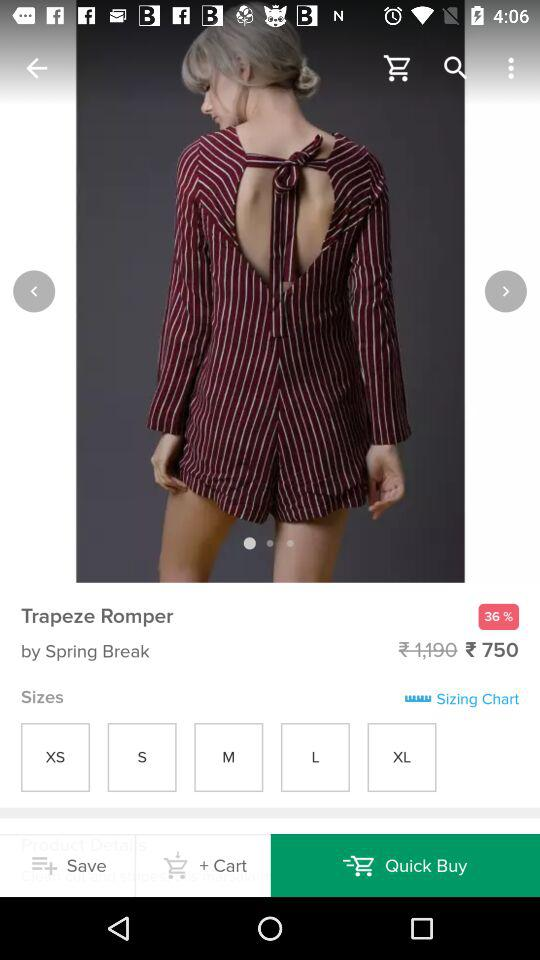Who designed the dress? The dress is designed by "Spring Break". 